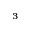<formula> <loc_0><loc_0><loc_500><loc_500>^ { 3 }</formula> 